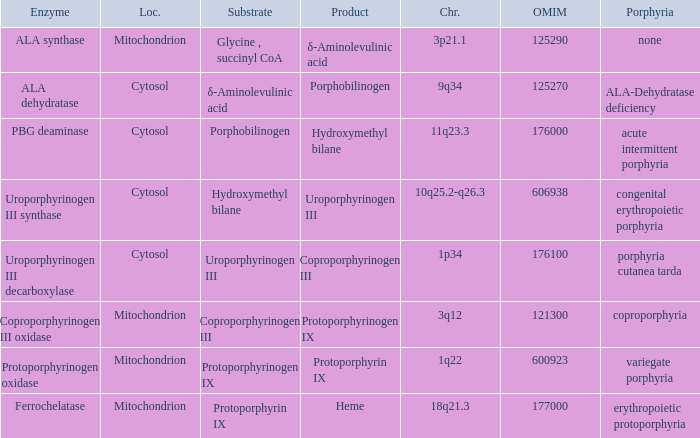Which substrate has an OMIM of 176000? Porphobilinogen. 